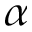<formula> <loc_0><loc_0><loc_500><loc_500>\alpha</formula> 